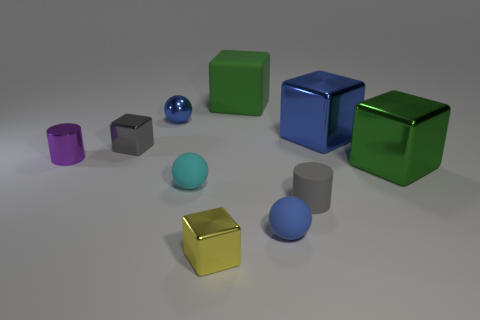Subtract all small blue balls. How many balls are left? 1 Subtract all gray cylinders. How many cylinders are left? 1 Subtract 1 spheres. How many spheres are left? 2 Subtract all yellow cylinders. How many green blocks are left? 2 Subtract 0 yellow cylinders. How many objects are left? 10 Subtract all balls. How many objects are left? 7 Subtract all cyan blocks. Subtract all green cylinders. How many blocks are left? 5 Subtract all small blue balls. Subtract all gray cubes. How many objects are left? 7 Add 5 small blue objects. How many small blue objects are left? 7 Add 6 big cyan cubes. How many big cyan cubes exist? 6 